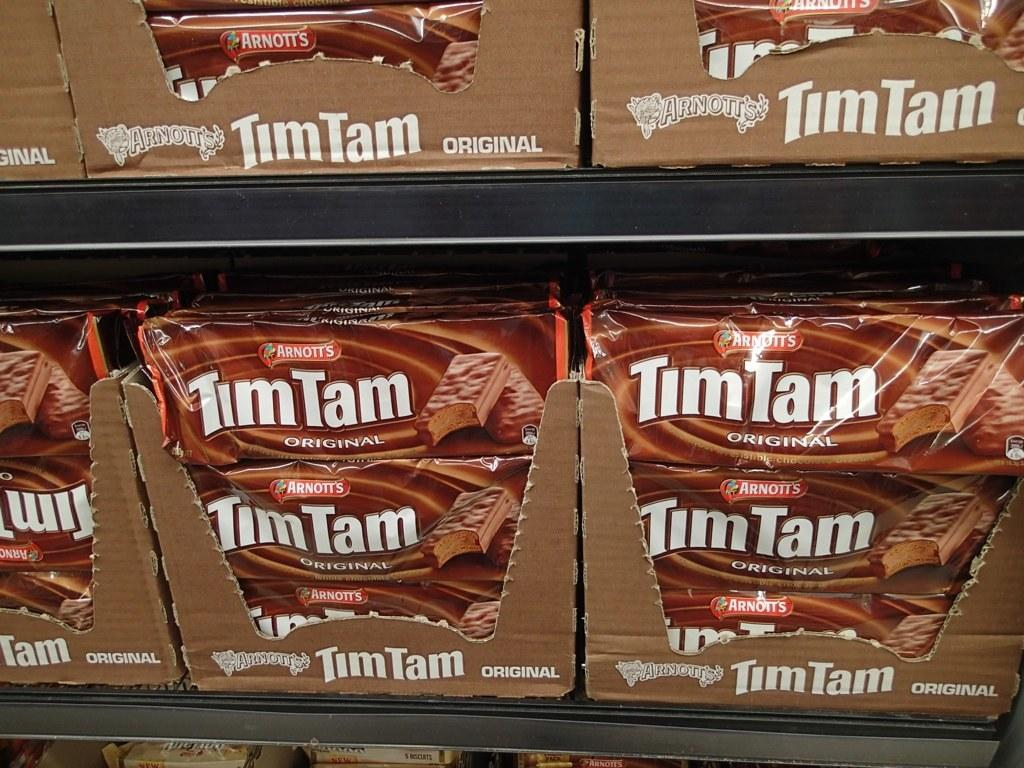What type of chocolates are featured in the image? There are Tim Tam chocolates in the image. How are the chocolates arranged in the image? The chocolates are arranged on racks. Can you see a kitten playing with the Tim Tam chocolates in the image? There is no kitten present in the image; it only features Tim Tam chocolates arranged on racks. What type of lumber is used to construct the racks in the image? The provided facts do not mention the type of lumber used to construct the racks, and therefore it cannot be determined from the image. 